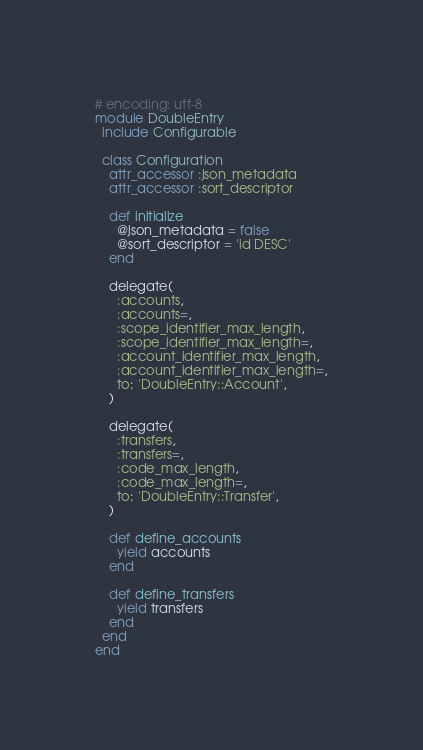<code> <loc_0><loc_0><loc_500><loc_500><_Ruby_># encoding: utf-8
module DoubleEntry
  include Configurable

  class Configuration
    attr_accessor :json_metadata
    attr_accessor :sort_descriptor

    def initialize
      @json_metadata = false
      @sort_descriptor = 'id DESC'
    end

    delegate(
      :accounts,
      :accounts=,
      :scope_identifier_max_length,
      :scope_identifier_max_length=,
      :account_identifier_max_length,
      :account_identifier_max_length=,
      to: 'DoubleEntry::Account',
    )

    delegate(
      :transfers,
      :transfers=,
      :code_max_length,
      :code_max_length=,
      to: 'DoubleEntry::Transfer',
    )

    def define_accounts
      yield accounts
    end

    def define_transfers
      yield transfers
    end
  end
end
</code> 